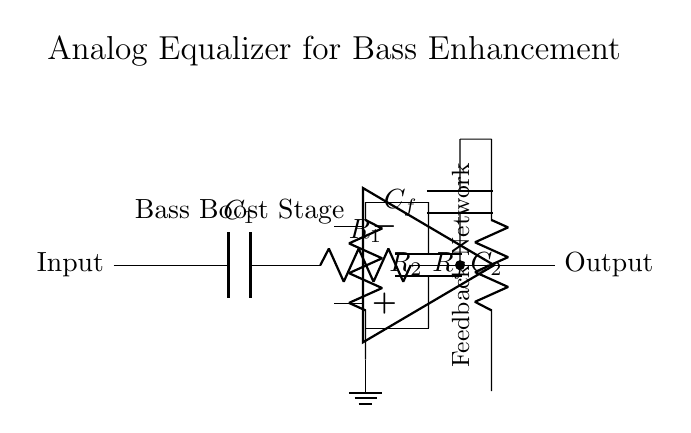What is the type of capacitor connected to the input? The capacitor connected to the input is labeled C1, which usually indicates a coupling capacitor in an audio circuit.
Answer: C1 What component is used to create feedback in this circuit? The resistor labeled Rf connects certain points in the circuit back to the input of the op-amp, creating a feedback loop essential for adjusting gain.
Answer: Rf What happens to the bass frequencies in this circuit? The circuit is designed specifically as a bass boost stage, indicating that it enhances lower frequency audio signals when connected to a vintage vinyl playback system.
Answer: Enhances How many resistors are in this circuit? There are three resistors labeled R1, R2, and Rf, showing that resistive components are used for various roles in shaping the signal throughout the circuit.
Answer: Three What does the feedback network consist of? The feedback network in this circuit mainly consists of the resistor Rf and capacitor Cf, which work together to control the gain and frequency response of the signal.
Answer: Rf and Cf What is the primary function of this circuit? The main function of the analog equalizer circuit is to selectively enhance bass frequencies and improve the overall quality of sound from vintage vinyl playback.
Answer: Bass enhancement 